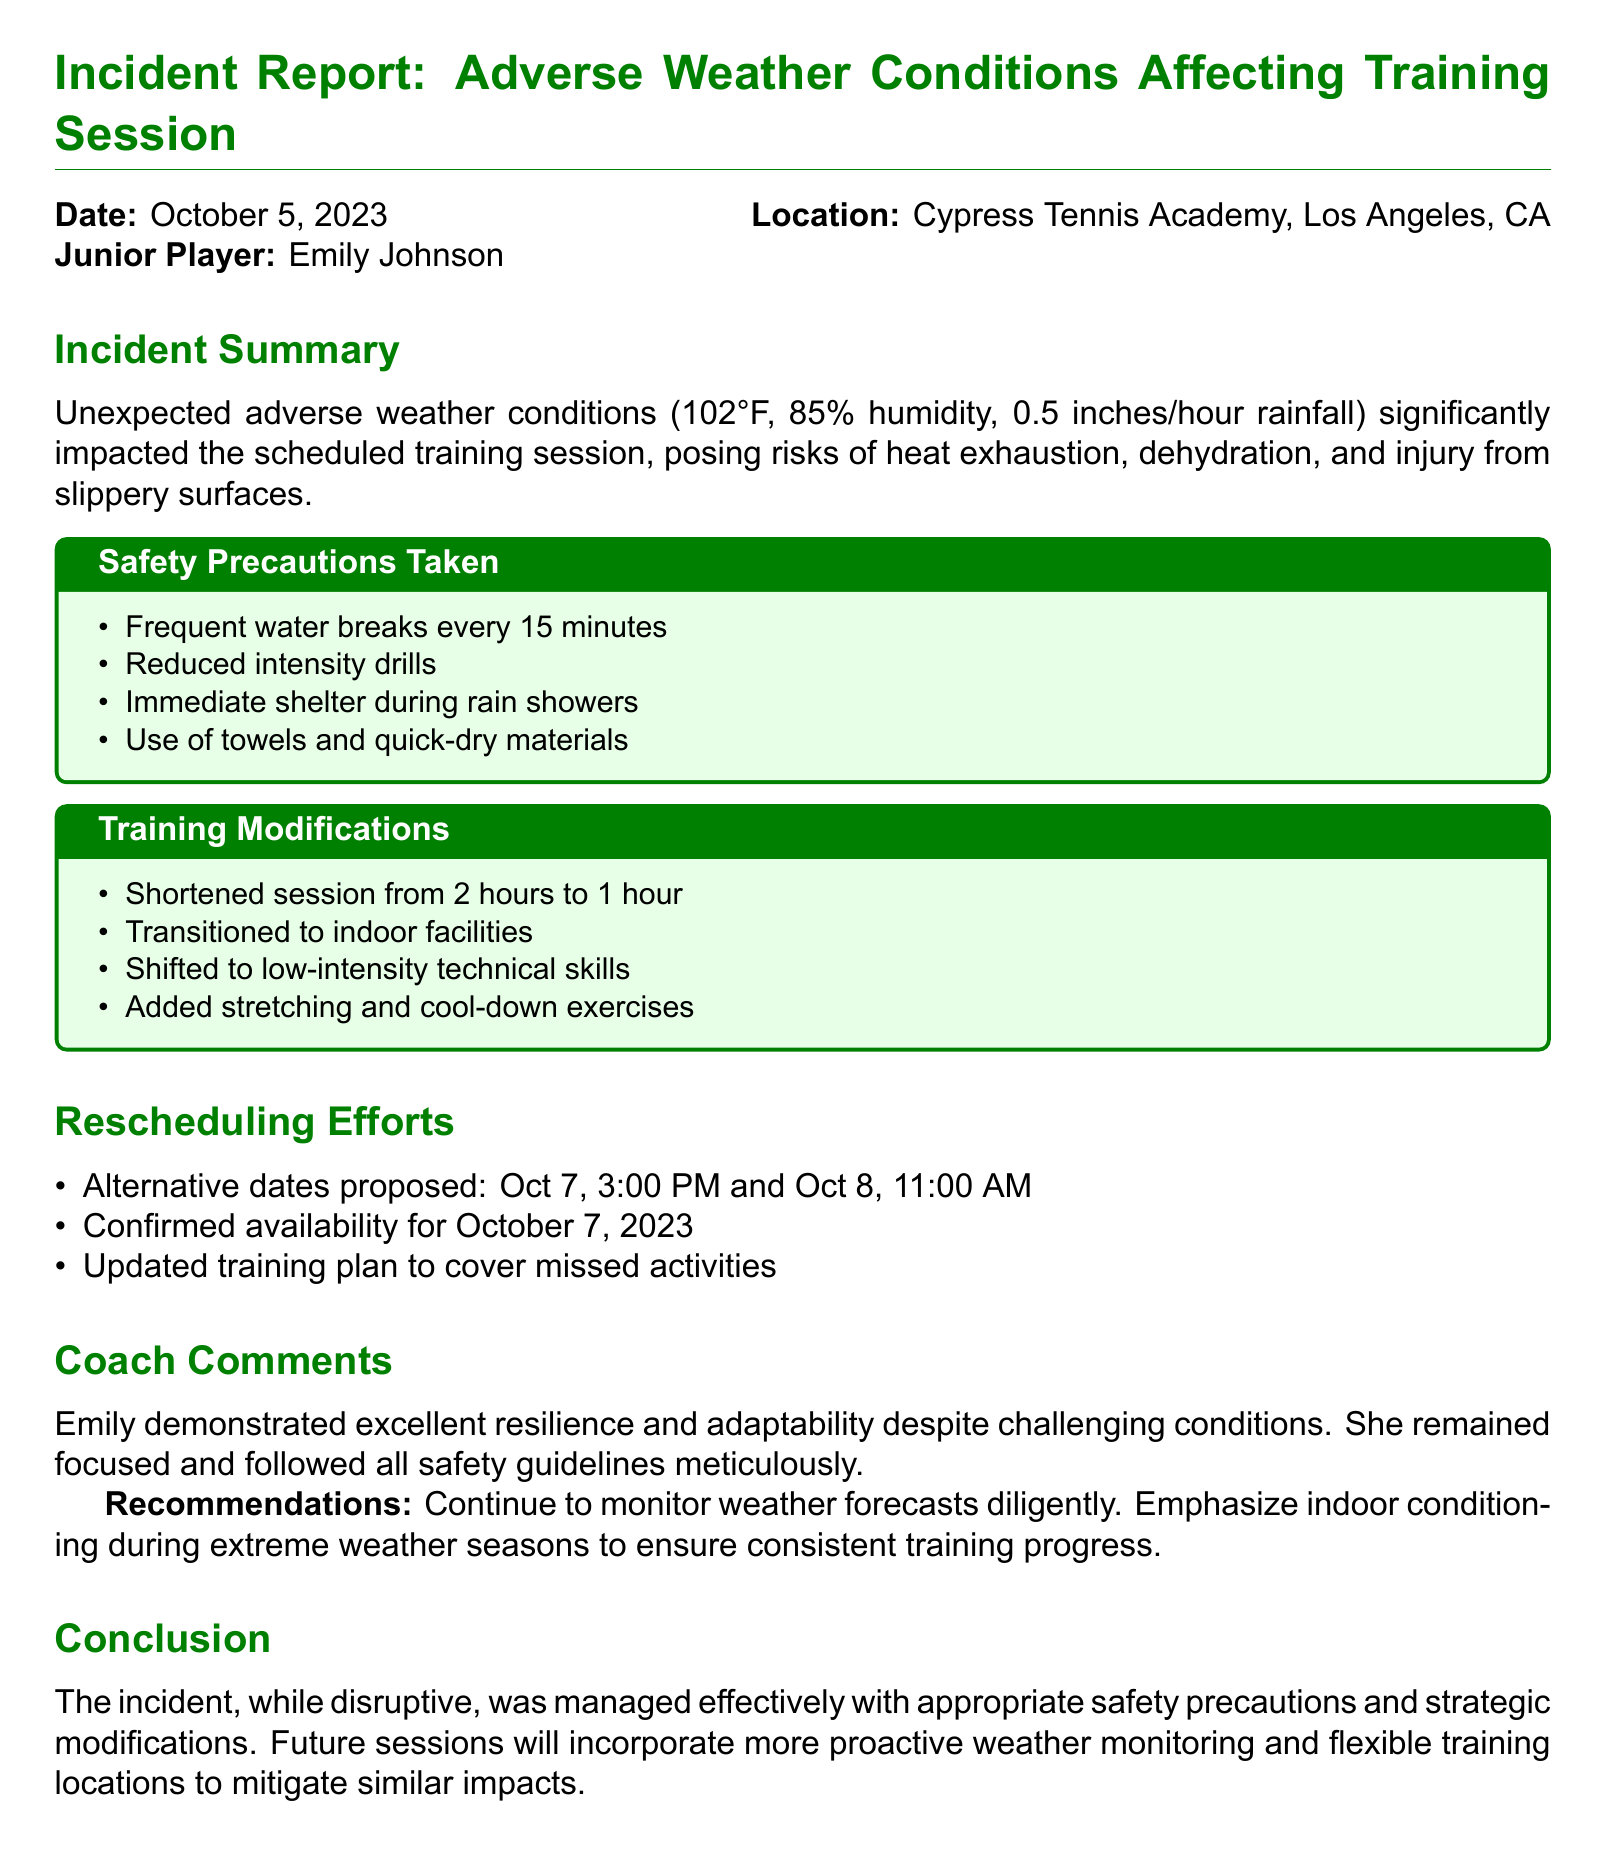what was the date of the incident? The date of the incident report is explicitly stated in the document.
Answer: October 5, 2023 who is the junior player involved? The document specifies the name of the junior player affected by the adverse weather conditions.
Answer: Emily Johnson what was the temperature during the incident? The temperature is mentioned in the incident summary section of the document.
Answer: 102°F what safety precaution was implemented every 15 minutes? The document lists frequent water breaks as a safety measure taken during the training session.
Answer: water breaks how long was the training session shortened to? The modification section details how the training session duration was altered.
Answer: 1 hour what was the proposed alternative date for rescheduling? The section on rescheduling efforts provides specific dates proposed for the alternative training session.
Answer: October 7, 3:00 PM what type of exercises were added to the training plan? The modifications specify additional components included in the training to adapt to the conditions.
Answer: stretching and cool-down exercises what indoor facilities were used during the training modification? The document indicates that the training was transitioned to a specific type of venue.
Answer: indoor facilities how did the coach describe Emily’s response to the situation? The coach's comments in the report provide insight into Emily's behavior during the training session.
Answer: excellent resilience and adaptability 